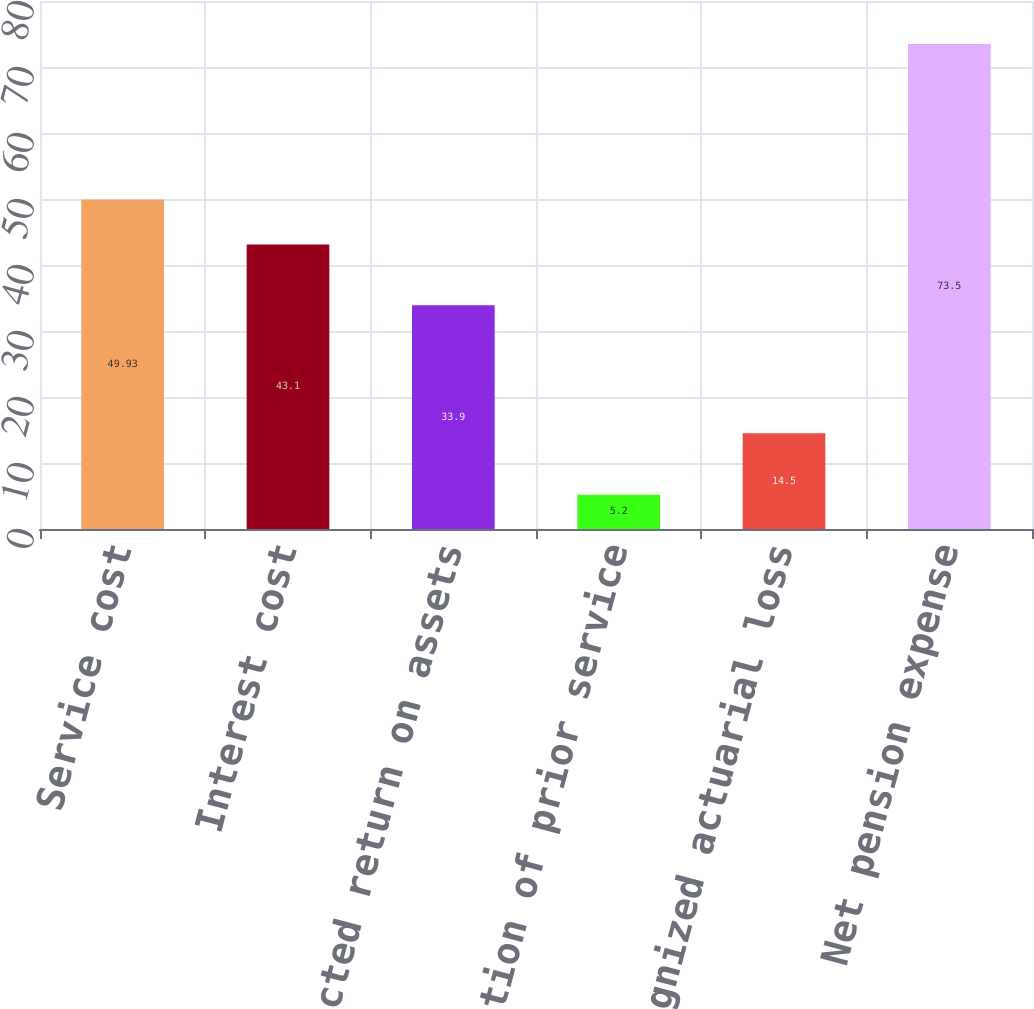Convert chart. <chart><loc_0><loc_0><loc_500><loc_500><bar_chart><fcel>Service cost<fcel>Interest cost<fcel>Expected return on assets<fcel>Amortization of prior service<fcel>Recognized actuarial loss<fcel>Net pension expense<nl><fcel>49.93<fcel>43.1<fcel>33.9<fcel>5.2<fcel>14.5<fcel>73.5<nl></chart> 